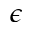Convert formula to latex. <formula><loc_0><loc_0><loc_500><loc_500>\epsilon</formula> 